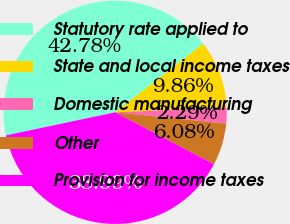Convert chart to OTSL. <chart><loc_0><loc_0><loc_500><loc_500><pie_chart><fcel>Statutory rate applied to<fcel>State and local income taxes<fcel>Domestic manufacturing<fcel>Other<fcel>Provision for income taxes<nl><fcel>42.78%<fcel>9.86%<fcel>2.29%<fcel>6.08%<fcel>38.99%<nl></chart> 